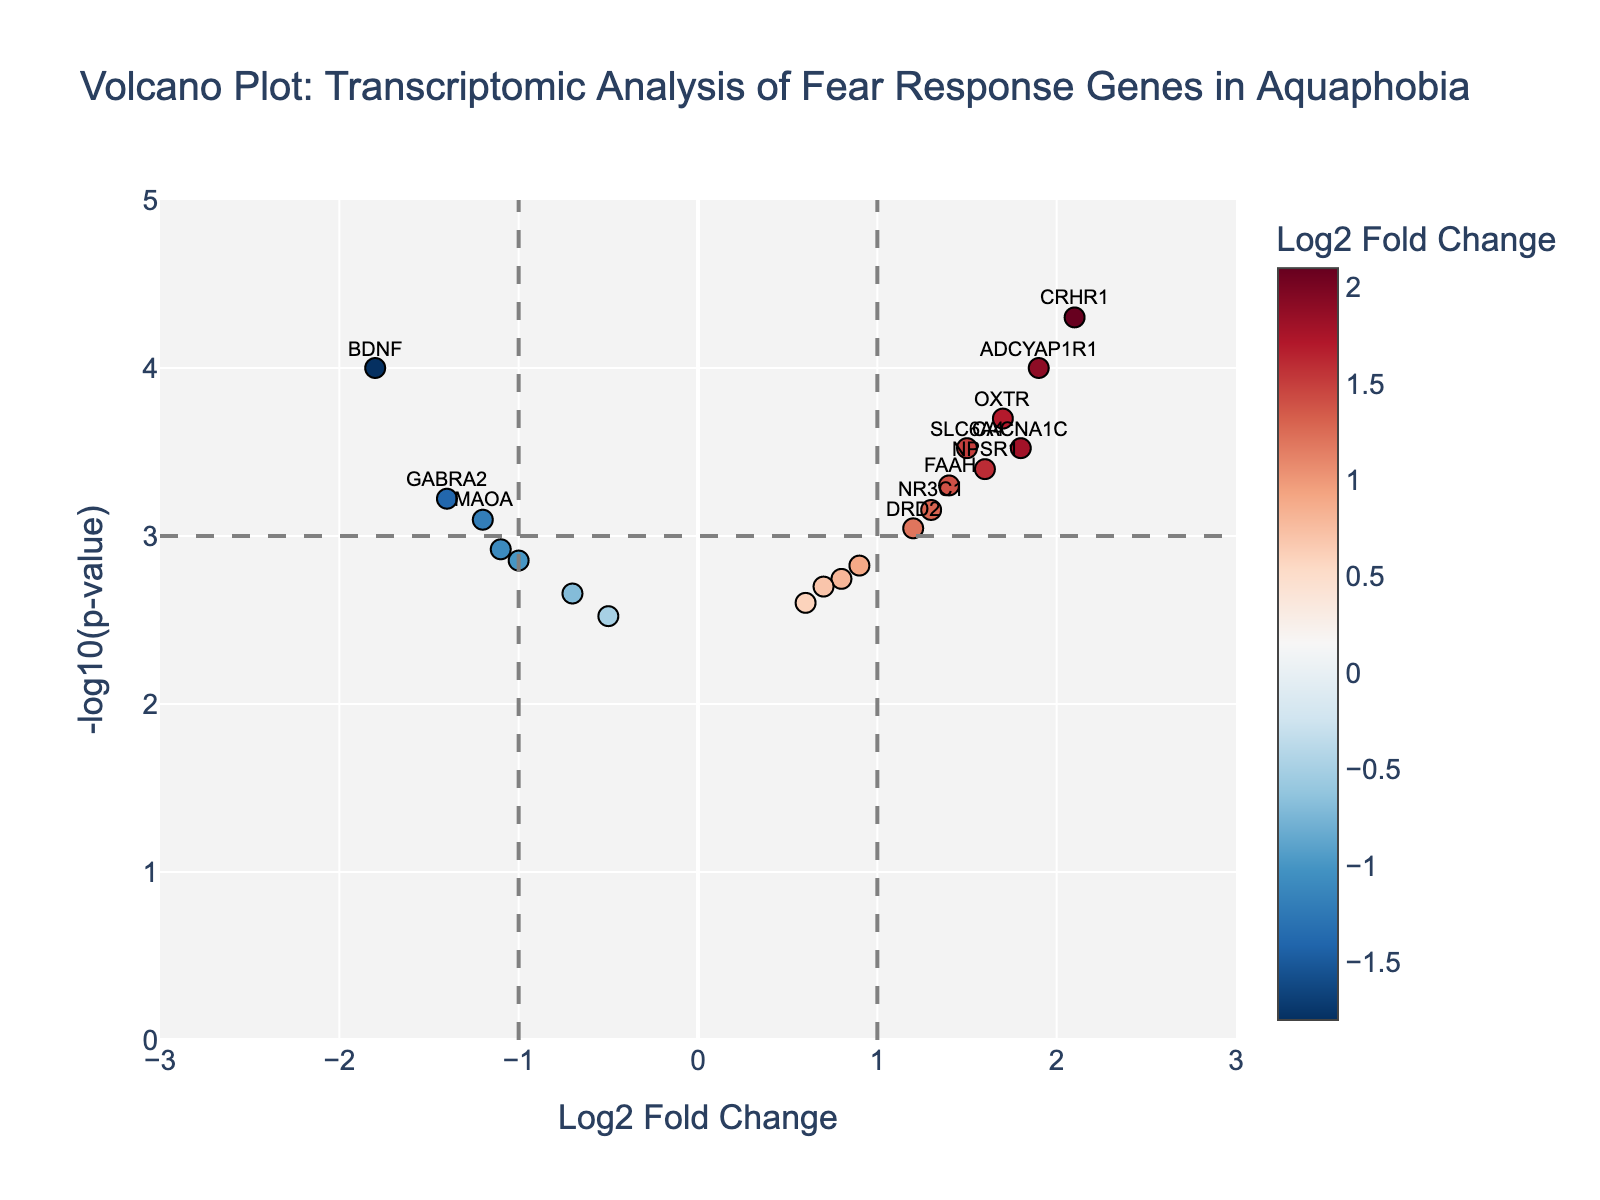What is the title of the volcano plot? The title of the plot is located at the top center and it summarizes the plot's content. It reads: Volcano Plot: Transcriptomic Analysis of Fear Response Genes in Aquaphobia.
Answer: Volcano Plot: Transcriptomic Analysis of Fear Response Genes in Aquaphobia What do the x-axis and y-axis represent in the plot? The x-axis is labeled as "Log2 Fold Change," indicating the log2 scale of the fold change in gene expression between aquaphobia patients and non-phobic individuals. The y-axis is labeled as "-log10(p-value)," representing the negative log10 of the p-values for each gene.
Answer: The x-axis shows Log2 Fold Change, and the y-axis shows -log10(p-value) Which gene has the highest log2 fold change? To find the highest log2 fold change, look for the data point with the highest value on the x-axis. The point representing the gene CRHR1 is located farthest to the right on the x-axis with a log2 fold change of 2.1.
Answer: CRHR1 How many genes are labeled as significant based on the plot's criteria? Significant genes are annotated textually on the plot and fall outside the established thresholds for fold change (>1 or <-1) and p-value (<0.001). By counting these annotated labels, we see there are six significant genes labeled: BDNF, SLC6A4, OXTR, CRHR1, ADCYAP1R1, and CACNA1C.
Answer: Six genes Which gene has the most significant p-value? The most significant p-value corresponds to the highest -log10(p-value) on the y-axis. The gene CRHR1, located at the top of the plot, has the highest -log10(p-value) around 4.3, indicating the lowest p-value.
Answer: CRHR1 What is the log2 fold change and p-value for the gene BDNF? The gene BDNF is annotated on the plot. From its position, the log2 fold change is approximately -1.8 and the p-value can be found directly in the figure's hover text for this point. The hover text reveals BDNF's p-value is 0.0001.
Answer: Log2 fold change: -1.8, P-value: 0.0001 Compare the fold change values between genes SLC6A4 and MAOA. Which one has a higher value? The plot shows SLC6A4 with a log2 fold change of approximately 1.5 and MAOA with a log2 fold change of -1.2. Comparing these values, SLC6A4 has a higher log2 fold change since 1.5 is greater than -1.2.
Answer: SLC6A4 What can be deduced about the gene expression trend for the genes labeled in the plot? By examining the log2 fold change values of the labeled genes, the trend can be deduced. Genes like SLC6A4, OXTR, CRHR1, ADCYAP1R1, and CACNA1C with positive log2 fold changes indicate they are upregulated, while BDNF with a negative log2 fold change indicates downregulation in aquaphobia patients.
Answer: Upregulated: SLC6A4, OXTR, CRHR1, ADCYAP1R1, CACNA1C; Downregulated: BDNF Which gene is closest to the threshold for significance but does not pass both criteria? To find the gene that is closest to the significance threshold but does not pass both criteria, observe the points near the dashed lines indicating thresholds. SLC6A6 with a log2 fold change just over 1 might be closest but doesn't have a p-value below the significant threshold.
Answer: SLC6A2 